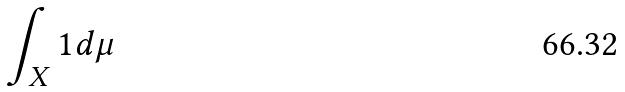<formula> <loc_0><loc_0><loc_500><loc_500>\int _ { X } 1 d \mu</formula> 